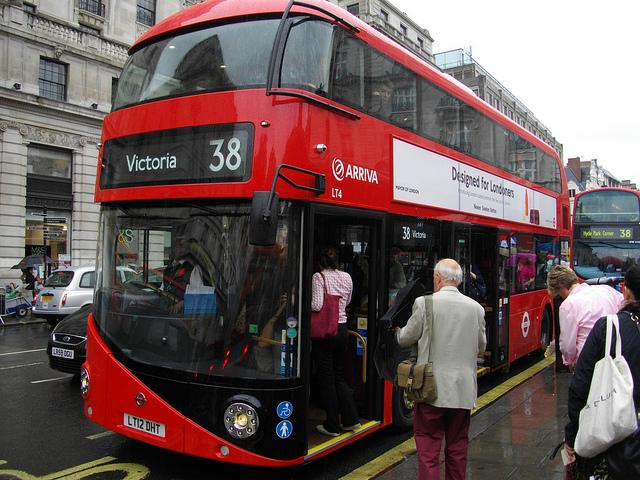What are these people waiting to do? board bus 